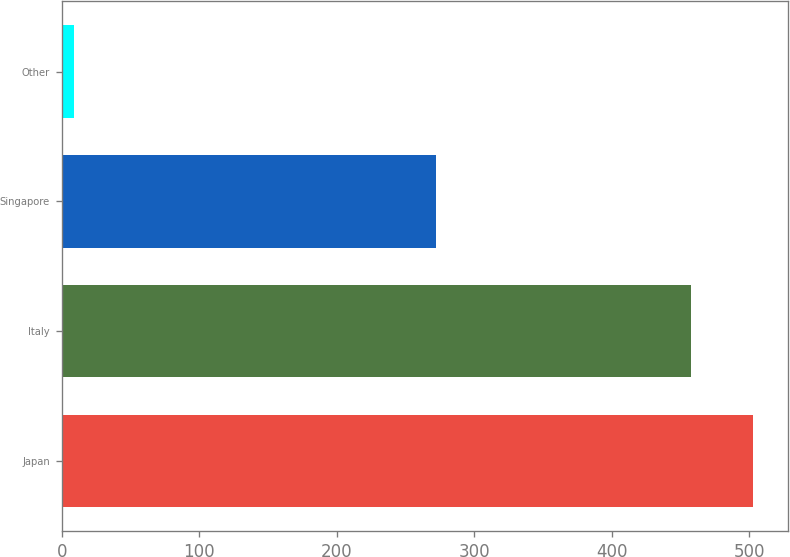Convert chart. <chart><loc_0><loc_0><loc_500><loc_500><bar_chart><fcel>Japan<fcel>Italy<fcel>Singapore<fcel>Other<nl><fcel>502.84<fcel>457.7<fcel>272<fcel>8.7<nl></chart> 